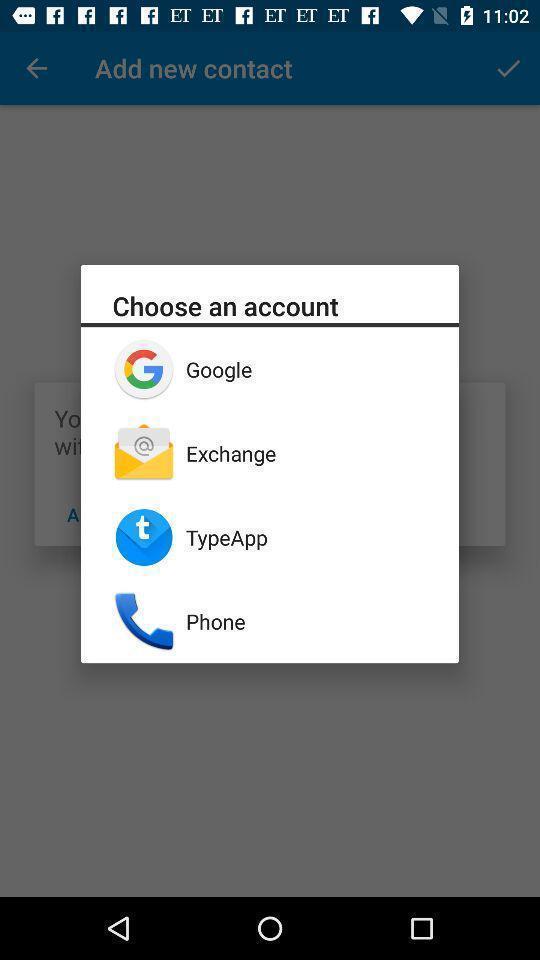What is the overall content of this screenshot? Popup to choose an account in the application. 